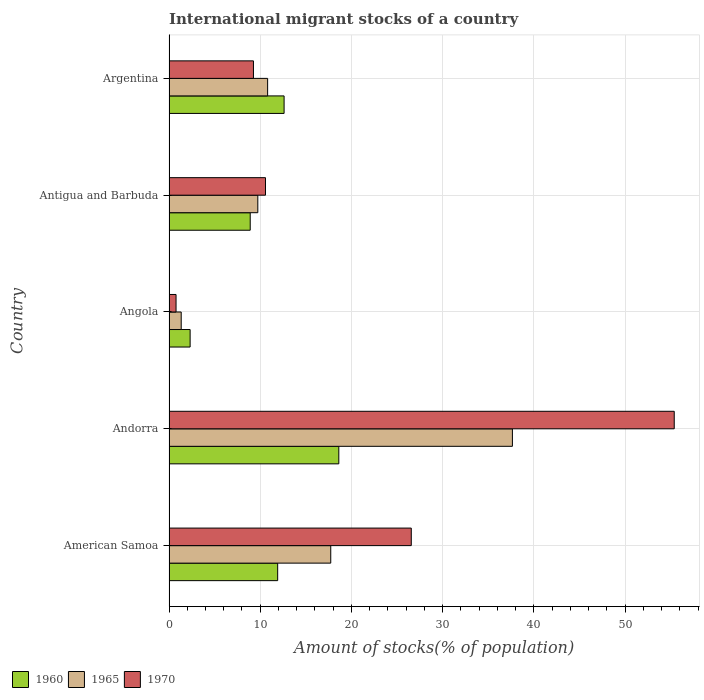How many bars are there on the 5th tick from the bottom?
Your response must be concise. 3. What is the label of the 3rd group of bars from the top?
Your answer should be compact. Angola. In how many cases, is the number of bars for a given country not equal to the number of legend labels?
Your response must be concise. 0. What is the amount of stocks in in 1970 in Andorra?
Provide a succinct answer. 55.38. Across all countries, what is the maximum amount of stocks in in 1970?
Make the answer very short. 55.38. Across all countries, what is the minimum amount of stocks in in 1970?
Offer a very short reply. 0.77. In which country was the amount of stocks in in 1960 maximum?
Provide a short and direct response. Andorra. In which country was the amount of stocks in in 1960 minimum?
Provide a succinct answer. Angola. What is the total amount of stocks in in 1960 in the graph?
Your answer should be compact. 54.36. What is the difference between the amount of stocks in in 1965 in American Samoa and that in Andorra?
Your response must be concise. -19.91. What is the difference between the amount of stocks in in 1960 in Antigua and Barbuda and the amount of stocks in in 1965 in Angola?
Offer a very short reply. 7.57. What is the average amount of stocks in in 1960 per country?
Your answer should be compact. 10.87. What is the difference between the amount of stocks in in 1965 and amount of stocks in in 1960 in Antigua and Barbuda?
Ensure brevity in your answer.  0.83. What is the ratio of the amount of stocks in in 1960 in Andorra to that in Argentina?
Your answer should be compact. 1.48. Is the amount of stocks in in 1970 in Angola less than that in Antigua and Barbuda?
Your answer should be very brief. Yes. Is the difference between the amount of stocks in in 1965 in Angola and Argentina greater than the difference between the amount of stocks in in 1960 in Angola and Argentina?
Provide a succinct answer. Yes. What is the difference between the highest and the second highest amount of stocks in in 1965?
Keep it short and to the point. 19.91. What is the difference between the highest and the lowest amount of stocks in in 1970?
Offer a very short reply. 54.61. In how many countries, is the amount of stocks in in 1970 greater than the average amount of stocks in in 1970 taken over all countries?
Your answer should be compact. 2. Is the sum of the amount of stocks in in 1965 in Antigua and Barbuda and Argentina greater than the maximum amount of stocks in in 1970 across all countries?
Your response must be concise. No. What does the 1st bar from the top in American Samoa represents?
Your response must be concise. 1970. Is it the case that in every country, the sum of the amount of stocks in in 1970 and amount of stocks in in 1960 is greater than the amount of stocks in in 1965?
Give a very brief answer. Yes. Are all the bars in the graph horizontal?
Provide a short and direct response. Yes. How many countries are there in the graph?
Provide a succinct answer. 5. Are the values on the major ticks of X-axis written in scientific E-notation?
Your answer should be compact. No. Does the graph contain any zero values?
Your response must be concise. No. Does the graph contain grids?
Ensure brevity in your answer.  Yes. Where does the legend appear in the graph?
Keep it short and to the point. Bottom left. How are the legend labels stacked?
Keep it short and to the point. Horizontal. What is the title of the graph?
Offer a very short reply. International migrant stocks of a country. Does "2015" appear as one of the legend labels in the graph?
Ensure brevity in your answer.  No. What is the label or title of the X-axis?
Offer a terse response. Amount of stocks(% of population). What is the Amount of stocks(% of population) of 1960 in American Samoa?
Ensure brevity in your answer.  11.91. What is the Amount of stocks(% of population) in 1965 in American Samoa?
Provide a short and direct response. 17.73. What is the Amount of stocks(% of population) of 1970 in American Samoa?
Your response must be concise. 26.56. What is the Amount of stocks(% of population) in 1960 in Andorra?
Your answer should be compact. 18.61. What is the Amount of stocks(% of population) of 1965 in Andorra?
Keep it short and to the point. 37.64. What is the Amount of stocks(% of population) of 1970 in Andorra?
Keep it short and to the point. 55.38. What is the Amount of stocks(% of population) in 1960 in Angola?
Keep it short and to the point. 2.32. What is the Amount of stocks(% of population) in 1965 in Angola?
Your answer should be very brief. 1.34. What is the Amount of stocks(% of population) in 1970 in Angola?
Your answer should be very brief. 0.77. What is the Amount of stocks(% of population) in 1960 in Antigua and Barbuda?
Ensure brevity in your answer.  8.9. What is the Amount of stocks(% of population) of 1965 in Antigua and Barbuda?
Provide a succinct answer. 9.73. What is the Amount of stocks(% of population) in 1970 in Antigua and Barbuda?
Offer a terse response. 10.58. What is the Amount of stocks(% of population) in 1960 in Argentina?
Keep it short and to the point. 12.62. What is the Amount of stocks(% of population) in 1965 in Argentina?
Your answer should be compact. 10.81. What is the Amount of stocks(% of population) in 1970 in Argentina?
Give a very brief answer. 9.26. Across all countries, what is the maximum Amount of stocks(% of population) of 1960?
Provide a succinct answer. 18.61. Across all countries, what is the maximum Amount of stocks(% of population) of 1965?
Give a very brief answer. 37.64. Across all countries, what is the maximum Amount of stocks(% of population) of 1970?
Offer a terse response. 55.38. Across all countries, what is the minimum Amount of stocks(% of population) of 1960?
Your response must be concise. 2.32. Across all countries, what is the minimum Amount of stocks(% of population) of 1965?
Keep it short and to the point. 1.34. Across all countries, what is the minimum Amount of stocks(% of population) of 1970?
Ensure brevity in your answer.  0.77. What is the total Amount of stocks(% of population) of 1960 in the graph?
Provide a succinct answer. 54.36. What is the total Amount of stocks(% of population) of 1965 in the graph?
Your answer should be very brief. 77.26. What is the total Amount of stocks(% of population) in 1970 in the graph?
Provide a short and direct response. 102.55. What is the difference between the Amount of stocks(% of population) of 1960 in American Samoa and that in Andorra?
Your answer should be compact. -6.7. What is the difference between the Amount of stocks(% of population) in 1965 in American Samoa and that in Andorra?
Provide a short and direct response. -19.91. What is the difference between the Amount of stocks(% of population) in 1970 in American Samoa and that in Andorra?
Make the answer very short. -28.82. What is the difference between the Amount of stocks(% of population) in 1960 in American Samoa and that in Angola?
Give a very brief answer. 9.6. What is the difference between the Amount of stocks(% of population) in 1965 in American Samoa and that in Angola?
Make the answer very short. 16.39. What is the difference between the Amount of stocks(% of population) in 1970 in American Samoa and that in Angola?
Offer a terse response. 25.79. What is the difference between the Amount of stocks(% of population) of 1960 in American Samoa and that in Antigua and Barbuda?
Provide a succinct answer. 3.01. What is the difference between the Amount of stocks(% of population) in 1965 in American Samoa and that in Antigua and Barbuda?
Offer a very short reply. 8. What is the difference between the Amount of stocks(% of population) of 1970 in American Samoa and that in Antigua and Barbuda?
Ensure brevity in your answer.  15.98. What is the difference between the Amount of stocks(% of population) of 1960 in American Samoa and that in Argentina?
Provide a short and direct response. -0.7. What is the difference between the Amount of stocks(% of population) of 1965 in American Samoa and that in Argentina?
Make the answer very short. 6.92. What is the difference between the Amount of stocks(% of population) of 1970 in American Samoa and that in Argentina?
Your answer should be very brief. 17.3. What is the difference between the Amount of stocks(% of population) of 1960 in Andorra and that in Angola?
Ensure brevity in your answer.  16.3. What is the difference between the Amount of stocks(% of population) of 1965 in Andorra and that in Angola?
Offer a terse response. 36.31. What is the difference between the Amount of stocks(% of population) of 1970 in Andorra and that in Angola?
Your answer should be very brief. 54.61. What is the difference between the Amount of stocks(% of population) of 1960 in Andorra and that in Antigua and Barbuda?
Provide a short and direct response. 9.71. What is the difference between the Amount of stocks(% of population) of 1965 in Andorra and that in Antigua and Barbuda?
Ensure brevity in your answer.  27.91. What is the difference between the Amount of stocks(% of population) in 1970 in Andorra and that in Antigua and Barbuda?
Your answer should be very brief. 44.8. What is the difference between the Amount of stocks(% of population) of 1960 in Andorra and that in Argentina?
Provide a short and direct response. 6. What is the difference between the Amount of stocks(% of population) in 1965 in Andorra and that in Argentina?
Provide a short and direct response. 26.83. What is the difference between the Amount of stocks(% of population) of 1970 in Andorra and that in Argentina?
Your answer should be compact. 46.12. What is the difference between the Amount of stocks(% of population) of 1960 in Angola and that in Antigua and Barbuda?
Offer a very short reply. -6.59. What is the difference between the Amount of stocks(% of population) of 1965 in Angola and that in Antigua and Barbuda?
Offer a very short reply. -8.4. What is the difference between the Amount of stocks(% of population) of 1970 in Angola and that in Antigua and Barbuda?
Your answer should be compact. -9.8. What is the difference between the Amount of stocks(% of population) in 1960 in Angola and that in Argentina?
Give a very brief answer. -10.3. What is the difference between the Amount of stocks(% of population) of 1965 in Angola and that in Argentina?
Give a very brief answer. -9.47. What is the difference between the Amount of stocks(% of population) of 1970 in Angola and that in Argentina?
Offer a very short reply. -8.49. What is the difference between the Amount of stocks(% of population) in 1960 in Antigua and Barbuda and that in Argentina?
Ensure brevity in your answer.  -3.71. What is the difference between the Amount of stocks(% of population) in 1965 in Antigua and Barbuda and that in Argentina?
Your response must be concise. -1.08. What is the difference between the Amount of stocks(% of population) in 1970 in Antigua and Barbuda and that in Argentina?
Make the answer very short. 1.32. What is the difference between the Amount of stocks(% of population) of 1960 in American Samoa and the Amount of stocks(% of population) of 1965 in Andorra?
Ensure brevity in your answer.  -25.73. What is the difference between the Amount of stocks(% of population) of 1960 in American Samoa and the Amount of stocks(% of population) of 1970 in Andorra?
Offer a very short reply. -43.47. What is the difference between the Amount of stocks(% of population) of 1965 in American Samoa and the Amount of stocks(% of population) of 1970 in Andorra?
Offer a very short reply. -37.65. What is the difference between the Amount of stocks(% of population) of 1960 in American Samoa and the Amount of stocks(% of population) of 1965 in Angola?
Provide a short and direct response. 10.58. What is the difference between the Amount of stocks(% of population) of 1960 in American Samoa and the Amount of stocks(% of population) of 1970 in Angola?
Offer a terse response. 11.14. What is the difference between the Amount of stocks(% of population) of 1965 in American Samoa and the Amount of stocks(% of population) of 1970 in Angola?
Provide a short and direct response. 16.96. What is the difference between the Amount of stocks(% of population) of 1960 in American Samoa and the Amount of stocks(% of population) of 1965 in Antigua and Barbuda?
Your response must be concise. 2.18. What is the difference between the Amount of stocks(% of population) of 1960 in American Samoa and the Amount of stocks(% of population) of 1970 in Antigua and Barbuda?
Your answer should be compact. 1.34. What is the difference between the Amount of stocks(% of population) of 1965 in American Samoa and the Amount of stocks(% of population) of 1970 in Antigua and Barbuda?
Your answer should be very brief. 7.15. What is the difference between the Amount of stocks(% of population) in 1960 in American Samoa and the Amount of stocks(% of population) in 1965 in Argentina?
Your response must be concise. 1.1. What is the difference between the Amount of stocks(% of population) in 1960 in American Samoa and the Amount of stocks(% of population) in 1970 in Argentina?
Your answer should be very brief. 2.65. What is the difference between the Amount of stocks(% of population) of 1965 in American Samoa and the Amount of stocks(% of population) of 1970 in Argentina?
Give a very brief answer. 8.47. What is the difference between the Amount of stocks(% of population) of 1960 in Andorra and the Amount of stocks(% of population) of 1965 in Angola?
Offer a very short reply. 17.28. What is the difference between the Amount of stocks(% of population) of 1960 in Andorra and the Amount of stocks(% of population) of 1970 in Angola?
Ensure brevity in your answer.  17.84. What is the difference between the Amount of stocks(% of population) of 1965 in Andorra and the Amount of stocks(% of population) of 1970 in Angola?
Your answer should be compact. 36.87. What is the difference between the Amount of stocks(% of population) of 1960 in Andorra and the Amount of stocks(% of population) of 1965 in Antigua and Barbuda?
Your answer should be compact. 8.88. What is the difference between the Amount of stocks(% of population) in 1960 in Andorra and the Amount of stocks(% of population) in 1970 in Antigua and Barbuda?
Offer a very short reply. 8.04. What is the difference between the Amount of stocks(% of population) of 1965 in Andorra and the Amount of stocks(% of population) of 1970 in Antigua and Barbuda?
Your answer should be compact. 27.07. What is the difference between the Amount of stocks(% of population) of 1960 in Andorra and the Amount of stocks(% of population) of 1965 in Argentina?
Give a very brief answer. 7.8. What is the difference between the Amount of stocks(% of population) in 1960 in Andorra and the Amount of stocks(% of population) in 1970 in Argentina?
Keep it short and to the point. 9.36. What is the difference between the Amount of stocks(% of population) of 1965 in Andorra and the Amount of stocks(% of population) of 1970 in Argentina?
Keep it short and to the point. 28.38. What is the difference between the Amount of stocks(% of population) of 1960 in Angola and the Amount of stocks(% of population) of 1965 in Antigua and Barbuda?
Make the answer very short. -7.42. What is the difference between the Amount of stocks(% of population) of 1960 in Angola and the Amount of stocks(% of population) of 1970 in Antigua and Barbuda?
Make the answer very short. -8.26. What is the difference between the Amount of stocks(% of population) of 1965 in Angola and the Amount of stocks(% of population) of 1970 in Antigua and Barbuda?
Make the answer very short. -9.24. What is the difference between the Amount of stocks(% of population) in 1960 in Angola and the Amount of stocks(% of population) in 1965 in Argentina?
Your answer should be very brief. -8.5. What is the difference between the Amount of stocks(% of population) in 1960 in Angola and the Amount of stocks(% of population) in 1970 in Argentina?
Keep it short and to the point. -6.94. What is the difference between the Amount of stocks(% of population) of 1965 in Angola and the Amount of stocks(% of population) of 1970 in Argentina?
Provide a short and direct response. -7.92. What is the difference between the Amount of stocks(% of population) in 1960 in Antigua and Barbuda and the Amount of stocks(% of population) in 1965 in Argentina?
Make the answer very short. -1.91. What is the difference between the Amount of stocks(% of population) in 1960 in Antigua and Barbuda and the Amount of stocks(% of population) in 1970 in Argentina?
Provide a short and direct response. -0.36. What is the difference between the Amount of stocks(% of population) in 1965 in Antigua and Barbuda and the Amount of stocks(% of population) in 1970 in Argentina?
Make the answer very short. 0.48. What is the average Amount of stocks(% of population) of 1960 per country?
Keep it short and to the point. 10.87. What is the average Amount of stocks(% of population) in 1965 per country?
Offer a terse response. 15.45. What is the average Amount of stocks(% of population) in 1970 per country?
Your response must be concise. 20.51. What is the difference between the Amount of stocks(% of population) in 1960 and Amount of stocks(% of population) in 1965 in American Samoa?
Ensure brevity in your answer.  -5.82. What is the difference between the Amount of stocks(% of population) in 1960 and Amount of stocks(% of population) in 1970 in American Samoa?
Your answer should be very brief. -14.64. What is the difference between the Amount of stocks(% of population) of 1965 and Amount of stocks(% of population) of 1970 in American Samoa?
Your answer should be compact. -8.83. What is the difference between the Amount of stocks(% of population) in 1960 and Amount of stocks(% of population) in 1965 in Andorra?
Keep it short and to the point. -19.03. What is the difference between the Amount of stocks(% of population) of 1960 and Amount of stocks(% of population) of 1970 in Andorra?
Provide a short and direct response. -36.77. What is the difference between the Amount of stocks(% of population) in 1965 and Amount of stocks(% of population) in 1970 in Andorra?
Ensure brevity in your answer.  -17.74. What is the difference between the Amount of stocks(% of population) in 1960 and Amount of stocks(% of population) in 1965 in Angola?
Give a very brief answer. 0.98. What is the difference between the Amount of stocks(% of population) of 1960 and Amount of stocks(% of population) of 1970 in Angola?
Your response must be concise. 1.54. What is the difference between the Amount of stocks(% of population) in 1965 and Amount of stocks(% of population) in 1970 in Angola?
Your answer should be very brief. 0.56. What is the difference between the Amount of stocks(% of population) in 1960 and Amount of stocks(% of population) in 1965 in Antigua and Barbuda?
Provide a succinct answer. -0.83. What is the difference between the Amount of stocks(% of population) in 1960 and Amount of stocks(% of population) in 1970 in Antigua and Barbuda?
Keep it short and to the point. -1.67. What is the difference between the Amount of stocks(% of population) of 1965 and Amount of stocks(% of population) of 1970 in Antigua and Barbuda?
Keep it short and to the point. -0.84. What is the difference between the Amount of stocks(% of population) in 1960 and Amount of stocks(% of population) in 1965 in Argentina?
Your answer should be very brief. 1.8. What is the difference between the Amount of stocks(% of population) of 1960 and Amount of stocks(% of population) of 1970 in Argentina?
Your answer should be very brief. 3.36. What is the difference between the Amount of stocks(% of population) in 1965 and Amount of stocks(% of population) in 1970 in Argentina?
Offer a terse response. 1.55. What is the ratio of the Amount of stocks(% of population) of 1960 in American Samoa to that in Andorra?
Provide a short and direct response. 0.64. What is the ratio of the Amount of stocks(% of population) of 1965 in American Samoa to that in Andorra?
Provide a succinct answer. 0.47. What is the ratio of the Amount of stocks(% of population) in 1970 in American Samoa to that in Andorra?
Your answer should be compact. 0.48. What is the ratio of the Amount of stocks(% of population) in 1960 in American Samoa to that in Angola?
Keep it short and to the point. 5.14. What is the ratio of the Amount of stocks(% of population) in 1965 in American Samoa to that in Angola?
Your answer should be compact. 13.26. What is the ratio of the Amount of stocks(% of population) of 1970 in American Samoa to that in Angola?
Make the answer very short. 34.39. What is the ratio of the Amount of stocks(% of population) of 1960 in American Samoa to that in Antigua and Barbuda?
Offer a terse response. 1.34. What is the ratio of the Amount of stocks(% of population) of 1965 in American Samoa to that in Antigua and Barbuda?
Provide a short and direct response. 1.82. What is the ratio of the Amount of stocks(% of population) in 1970 in American Samoa to that in Antigua and Barbuda?
Give a very brief answer. 2.51. What is the ratio of the Amount of stocks(% of population) of 1960 in American Samoa to that in Argentina?
Your answer should be compact. 0.94. What is the ratio of the Amount of stocks(% of population) in 1965 in American Samoa to that in Argentina?
Your response must be concise. 1.64. What is the ratio of the Amount of stocks(% of population) of 1970 in American Samoa to that in Argentina?
Provide a short and direct response. 2.87. What is the ratio of the Amount of stocks(% of population) of 1960 in Andorra to that in Angola?
Give a very brief answer. 8.04. What is the ratio of the Amount of stocks(% of population) of 1965 in Andorra to that in Angola?
Offer a very short reply. 28.16. What is the ratio of the Amount of stocks(% of population) of 1970 in Andorra to that in Angola?
Provide a short and direct response. 71.72. What is the ratio of the Amount of stocks(% of population) of 1960 in Andorra to that in Antigua and Barbuda?
Keep it short and to the point. 2.09. What is the ratio of the Amount of stocks(% of population) in 1965 in Andorra to that in Antigua and Barbuda?
Keep it short and to the point. 3.87. What is the ratio of the Amount of stocks(% of population) in 1970 in Andorra to that in Antigua and Barbuda?
Offer a very short reply. 5.24. What is the ratio of the Amount of stocks(% of population) in 1960 in Andorra to that in Argentina?
Offer a very short reply. 1.48. What is the ratio of the Amount of stocks(% of population) in 1965 in Andorra to that in Argentina?
Provide a short and direct response. 3.48. What is the ratio of the Amount of stocks(% of population) in 1970 in Andorra to that in Argentina?
Offer a terse response. 5.98. What is the ratio of the Amount of stocks(% of population) in 1960 in Angola to that in Antigua and Barbuda?
Give a very brief answer. 0.26. What is the ratio of the Amount of stocks(% of population) of 1965 in Angola to that in Antigua and Barbuda?
Provide a short and direct response. 0.14. What is the ratio of the Amount of stocks(% of population) in 1970 in Angola to that in Antigua and Barbuda?
Your answer should be very brief. 0.07. What is the ratio of the Amount of stocks(% of population) of 1960 in Angola to that in Argentina?
Provide a short and direct response. 0.18. What is the ratio of the Amount of stocks(% of population) in 1965 in Angola to that in Argentina?
Make the answer very short. 0.12. What is the ratio of the Amount of stocks(% of population) in 1970 in Angola to that in Argentina?
Your answer should be compact. 0.08. What is the ratio of the Amount of stocks(% of population) in 1960 in Antigua and Barbuda to that in Argentina?
Provide a short and direct response. 0.71. What is the ratio of the Amount of stocks(% of population) of 1965 in Antigua and Barbuda to that in Argentina?
Provide a short and direct response. 0.9. What is the ratio of the Amount of stocks(% of population) in 1970 in Antigua and Barbuda to that in Argentina?
Your answer should be very brief. 1.14. What is the difference between the highest and the second highest Amount of stocks(% of population) of 1960?
Your answer should be compact. 6. What is the difference between the highest and the second highest Amount of stocks(% of population) in 1965?
Provide a succinct answer. 19.91. What is the difference between the highest and the second highest Amount of stocks(% of population) in 1970?
Offer a very short reply. 28.82. What is the difference between the highest and the lowest Amount of stocks(% of population) in 1960?
Make the answer very short. 16.3. What is the difference between the highest and the lowest Amount of stocks(% of population) in 1965?
Ensure brevity in your answer.  36.31. What is the difference between the highest and the lowest Amount of stocks(% of population) in 1970?
Ensure brevity in your answer.  54.61. 